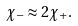<formula> <loc_0><loc_0><loc_500><loc_500>\chi _ { - } \approx 2 \chi _ { + } .</formula> 